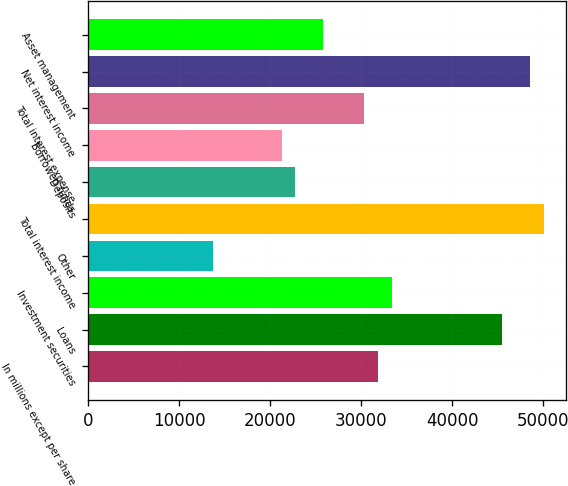Convert chart to OTSL. <chart><loc_0><loc_0><loc_500><loc_500><bar_chart><fcel>In millions except per share<fcel>Loans<fcel>Investment securities<fcel>Other<fcel>Total interest income<fcel>Deposits<fcel>Borrowed funds<fcel>Total interest expense<fcel>Net interest income<fcel>Asset management<nl><fcel>31864.1<fcel>45518<fcel>33381.2<fcel>13658.9<fcel>50069.3<fcel>22761.5<fcel>21244.4<fcel>30347<fcel>48552.2<fcel>25795.7<nl></chart> 